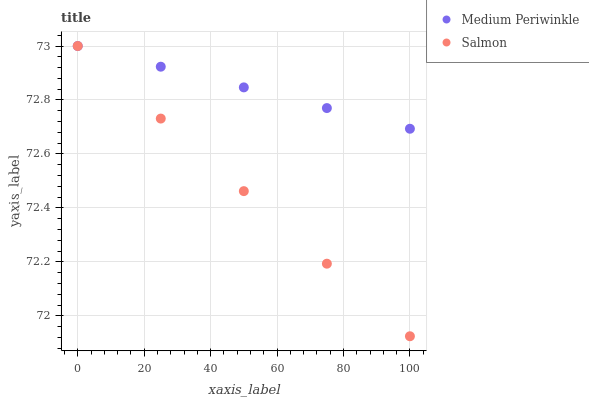Does Salmon have the minimum area under the curve?
Answer yes or no. Yes. Does Medium Periwinkle have the maximum area under the curve?
Answer yes or no. Yes. Does Medium Periwinkle have the minimum area under the curve?
Answer yes or no. No. Is Medium Periwinkle the smoothest?
Answer yes or no. Yes. Is Salmon the roughest?
Answer yes or no. Yes. Is Medium Periwinkle the roughest?
Answer yes or no. No. Does Salmon have the lowest value?
Answer yes or no. Yes. Does Medium Periwinkle have the lowest value?
Answer yes or no. No. Does Medium Periwinkle have the highest value?
Answer yes or no. Yes. Does Salmon intersect Medium Periwinkle?
Answer yes or no. Yes. Is Salmon less than Medium Periwinkle?
Answer yes or no. No. Is Salmon greater than Medium Periwinkle?
Answer yes or no. No. 